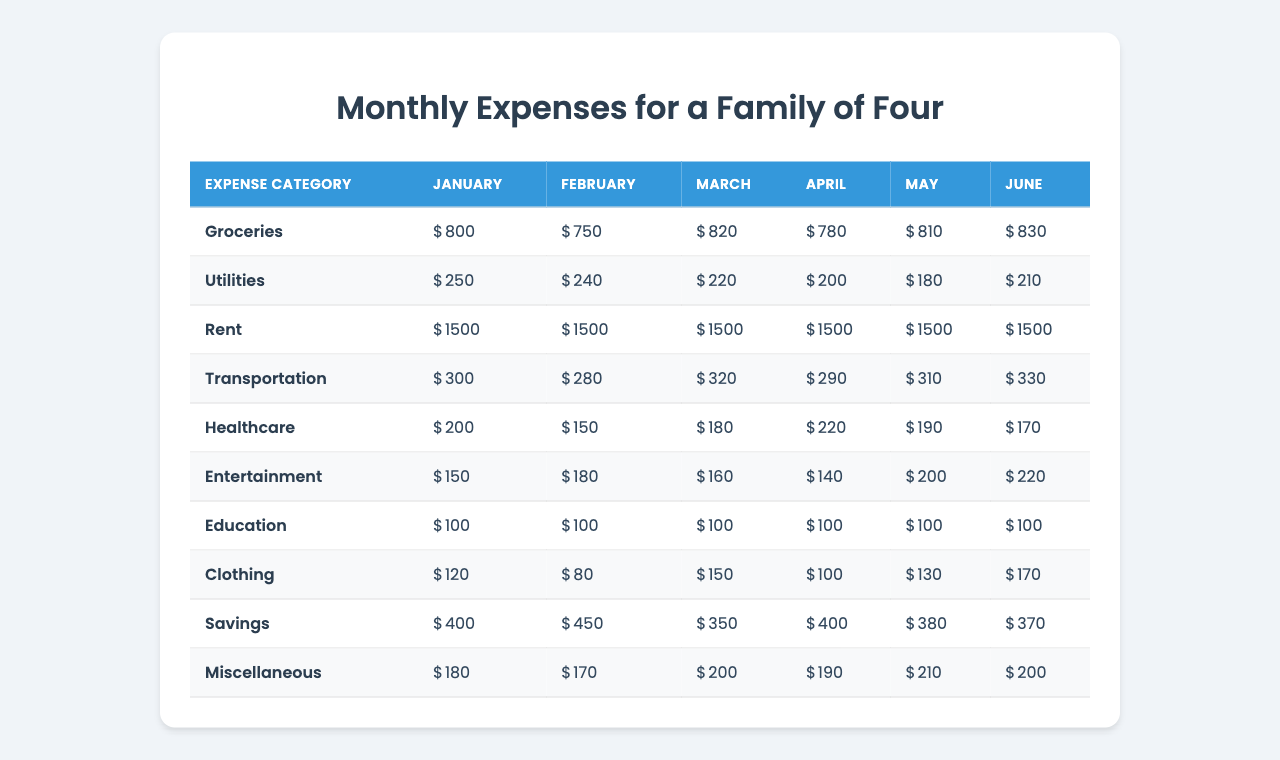What was the total expense on groceries in March? The grocery expense for March is listed as 820. Therefore, the total expense on groceries in March is simply that value.
Answer: 820 Which month had the highest utility expense? By examining the utility expenses across all months, we see 250 in January, 240 in February, 220 in March, 200 in April, 180 in May, and 210 in June. January shows the highest value.
Answer: January What is the average transportation expense over the six months? To find the average, we add the transportation expenses for each month (300 + 280 + 320 + 290 + 310 + 330 = 1830) and divide by the number of months (6). So, 1830/6 = 305.
Answer: 305 Is the healthcare expense in February higher than the utilities expense in the same month? The healthcare expense in February is 150 while the utilities expense is 240. Since 150 is less than 240, the statement is false.
Answer: No What was the change in entertainment expenses from February to March? The entertainment expense in February is 180, while in March it is 160. The change is calculated as 180 - 160 = 20.
Answer: 20 What is the total amount spent on rent over these six months? Rent is constant at 1500 each month. Multiplied by 6 months gives a total of 1500 * 6 = 9000.
Answer: 9000 Which category had the lowest expense in June? Looking at the June expenses, Clothing shows an expense of 170, which is the lowest when compared to other categories like Groceries (830), Utilities (210), etc.
Answer: Clothing What is the difference between the maximum and minimum expenses for savings in the recorded months? The savings expenses are as follows: 400, 450, 350, 400, 380, 370. The maximum is 450 and the minimum is 350. Therefore, the difference is 450 - 350 = 100.
Answer: 100 In which month did miscellaneous expenses peak? The miscellaneous expenses recorded are 180, 170, 200, 190, 210, and 200 for the respective months. The peak expense is 210 which occurred in May.
Answer: May What percentage of the total family monthly expenses does rent represent? First, we find the total monthly expenses by summing all categories for any month. For example, January totals to 800 + 250 + 1500 + 300 + 200 + 150 + 100 + 120 + 400 + 180 = 3000. Rent is 1500, so rent percentage is (1500 / 3000) * 100 = 50%.
Answer: 50% 